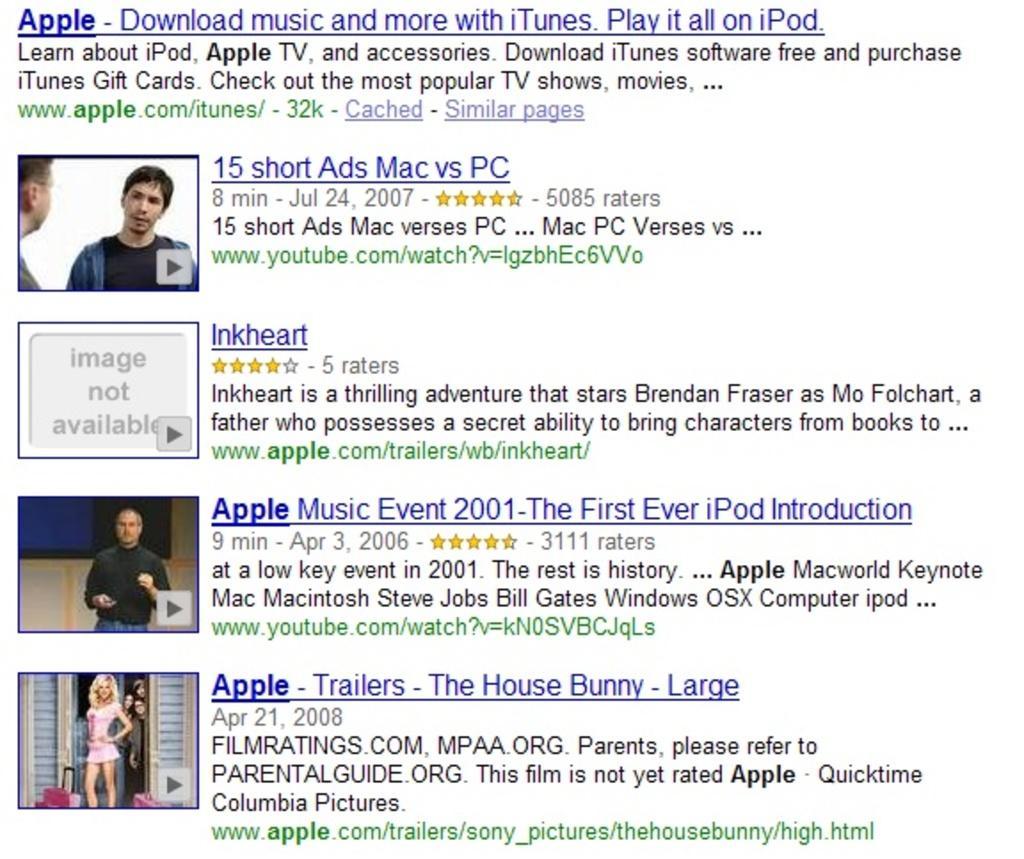Describe this image in one or two sentences. In this image we can see website links, video clips and something written under these website links. 